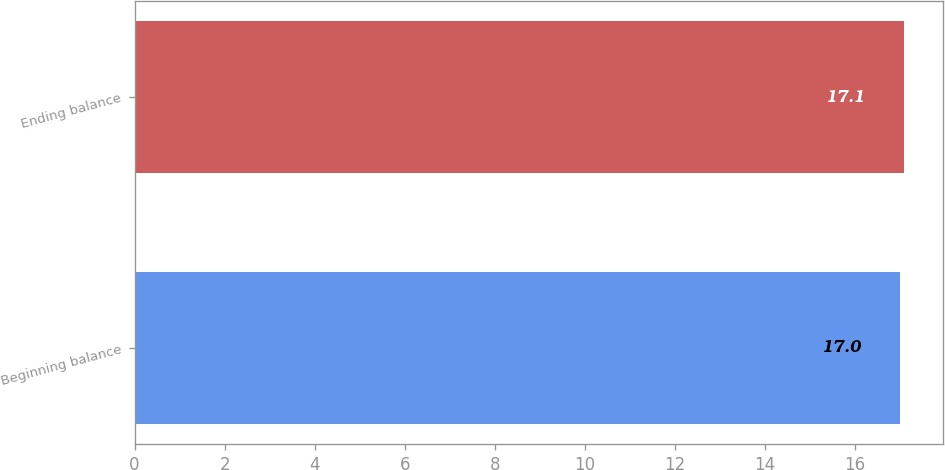<chart> <loc_0><loc_0><loc_500><loc_500><bar_chart><fcel>Beginning balance<fcel>Ending balance<nl><fcel>17<fcel>17.1<nl></chart> 